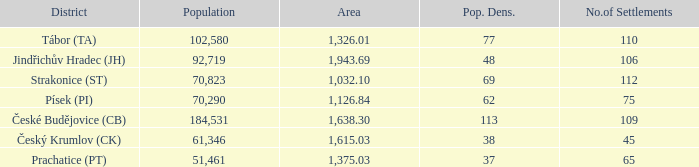What is the population density of the area with a population larger than 92,719? 2.0. 